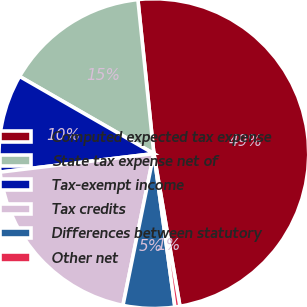Convert chart to OTSL. <chart><loc_0><loc_0><loc_500><loc_500><pie_chart><fcel>Computed expected tax expense<fcel>State tax expense net of<fcel>Tax-exempt income<fcel>Tax credits<fcel>Differences between statutory<fcel>Other net<nl><fcel>48.95%<fcel>15.05%<fcel>10.21%<fcel>19.9%<fcel>5.37%<fcel>0.52%<nl></chart> 